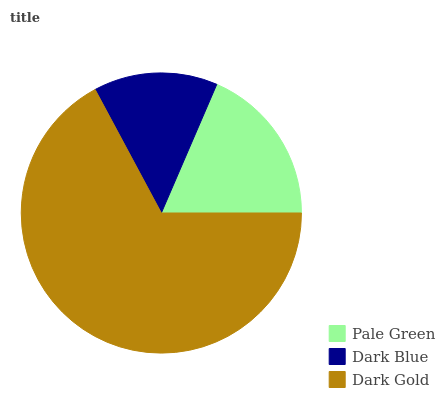Is Dark Blue the minimum?
Answer yes or no. Yes. Is Dark Gold the maximum?
Answer yes or no. Yes. Is Dark Gold the minimum?
Answer yes or no. No. Is Dark Blue the maximum?
Answer yes or no. No. Is Dark Gold greater than Dark Blue?
Answer yes or no. Yes. Is Dark Blue less than Dark Gold?
Answer yes or no. Yes. Is Dark Blue greater than Dark Gold?
Answer yes or no. No. Is Dark Gold less than Dark Blue?
Answer yes or no. No. Is Pale Green the high median?
Answer yes or no. Yes. Is Pale Green the low median?
Answer yes or no. Yes. Is Dark Gold the high median?
Answer yes or no. No. Is Dark Blue the low median?
Answer yes or no. No. 